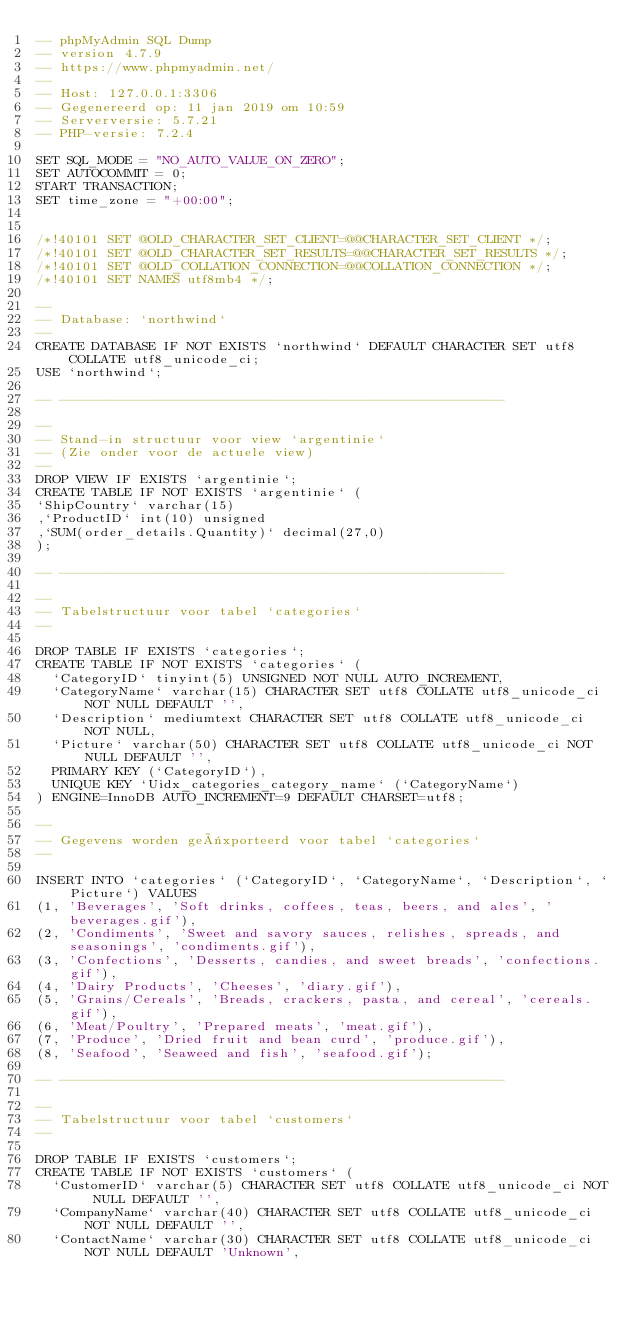Convert code to text. <code><loc_0><loc_0><loc_500><loc_500><_SQL_>-- phpMyAdmin SQL Dump
-- version 4.7.9
-- https://www.phpmyadmin.net/
--
-- Host: 127.0.0.1:3306
-- Gegenereerd op: 11 jan 2019 om 10:59
-- Serverversie: 5.7.21
-- PHP-versie: 7.2.4

SET SQL_MODE = "NO_AUTO_VALUE_ON_ZERO";
SET AUTOCOMMIT = 0;
START TRANSACTION;
SET time_zone = "+00:00";


/*!40101 SET @OLD_CHARACTER_SET_CLIENT=@@CHARACTER_SET_CLIENT */;
/*!40101 SET @OLD_CHARACTER_SET_RESULTS=@@CHARACTER_SET_RESULTS */;
/*!40101 SET @OLD_COLLATION_CONNECTION=@@COLLATION_CONNECTION */;
/*!40101 SET NAMES utf8mb4 */;

--
-- Database: `northwind`
--
CREATE DATABASE IF NOT EXISTS `northwind` DEFAULT CHARACTER SET utf8 COLLATE utf8_unicode_ci;
USE `northwind`;

-- --------------------------------------------------------

--
-- Stand-in structuur voor view `argentinie`
-- (Zie onder voor de actuele view)
--
DROP VIEW IF EXISTS `argentinie`;
CREATE TABLE IF NOT EXISTS `argentinie` (
`ShipCountry` varchar(15)
,`ProductID` int(10) unsigned
,`SUM(order_details.Quantity)` decimal(27,0)
);

-- --------------------------------------------------------

--
-- Tabelstructuur voor tabel `categories`
--

DROP TABLE IF EXISTS `categories`;
CREATE TABLE IF NOT EXISTS `categories` (
  `CategoryID` tinyint(5) UNSIGNED NOT NULL AUTO_INCREMENT,
  `CategoryName` varchar(15) CHARACTER SET utf8 COLLATE utf8_unicode_ci NOT NULL DEFAULT '',
  `Description` mediumtext CHARACTER SET utf8 COLLATE utf8_unicode_ci NOT NULL,
  `Picture` varchar(50) CHARACTER SET utf8 COLLATE utf8_unicode_ci NOT NULL DEFAULT '',
  PRIMARY KEY (`CategoryID`),
  UNIQUE KEY `Uidx_categories_category_name` (`CategoryName`)
) ENGINE=InnoDB AUTO_INCREMENT=9 DEFAULT CHARSET=utf8;

--
-- Gegevens worden geëxporteerd voor tabel `categories`
--

INSERT INTO `categories` (`CategoryID`, `CategoryName`, `Description`, `Picture`) VALUES
(1, 'Beverages', 'Soft drinks, coffees, teas, beers, and ales', 'beverages.gif'),
(2, 'Condiments', 'Sweet and savory sauces, relishes, spreads, and seasonings', 'condiments.gif'),
(3, 'Confections', 'Desserts, candies, and sweet breads', 'confections.gif'),
(4, 'Dairy Products', 'Cheeses', 'diary.gif'),
(5, 'Grains/Cereals', 'Breads, crackers, pasta, and cereal', 'cereals.gif'),
(6, 'Meat/Poultry', 'Prepared meats', 'meat.gif'),
(7, 'Produce', 'Dried fruit and bean curd', 'produce.gif'),
(8, 'Seafood', 'Seaweed and fish', 'seafood.gif');

-- --------------------------------------------------------

--
-- Tabelstructuur voor tabel `customers`
--

DROP TABLE IF EXISTS `customers`;
CREATE TABLE IF NOT EXISTS `customers` (
  `CustomerID` varchar(5) CHARACTER SET utf8 COLLATE utf8_unicode_ci NOT NULL DEFAULT '',
  `CompanyName` varchar(40) CHARACTER SET utf8 COLLATE utf8_unicode_ci NOT NULL DEFAULT '',
  `ContactName` varchar(30) CHARACTER SET utf8 COLLATE utf8_unicode_ci NOT NULL DEFAULT 'Unknown',</code> 